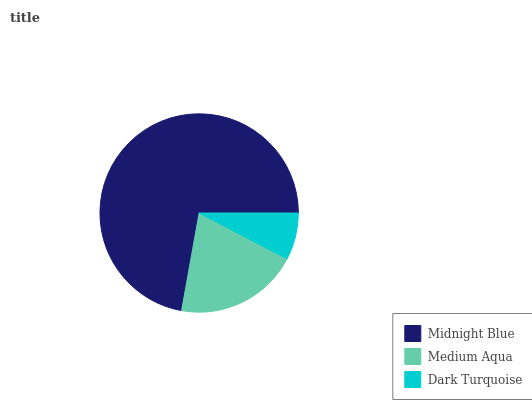Is Dark Turquoise the minimum?
Answer yes or no. Yes. Is Midnight Blue the maximum?
Answer yes or no. Yes. Is Medium Aqua the minimum?
Answer yes or no. No. Is Medium Aqua the maximum?
Answer yes or no. No. Is Midnight Blue greater than Medium Aqua?
Answer yes or no. Yes. Is Medium Aqua less than Midnight Blue?
Answer yes or no. Yes. Is Medium Aqua greater than Midnight Blue?
Answer yes or no. No. Is Midnight Blue less than Medium Aqua?
Answer yes or no. No. Is Medium Aqua the high median?
Answer yes or no. Yes. Is Medium Aqua the low median?
Answer yes or no. Yes. Is Dark Turquoise the high median?
Answer yes or no. No. Is Dark Turquoise the low median?
Answer yes or no. No. 